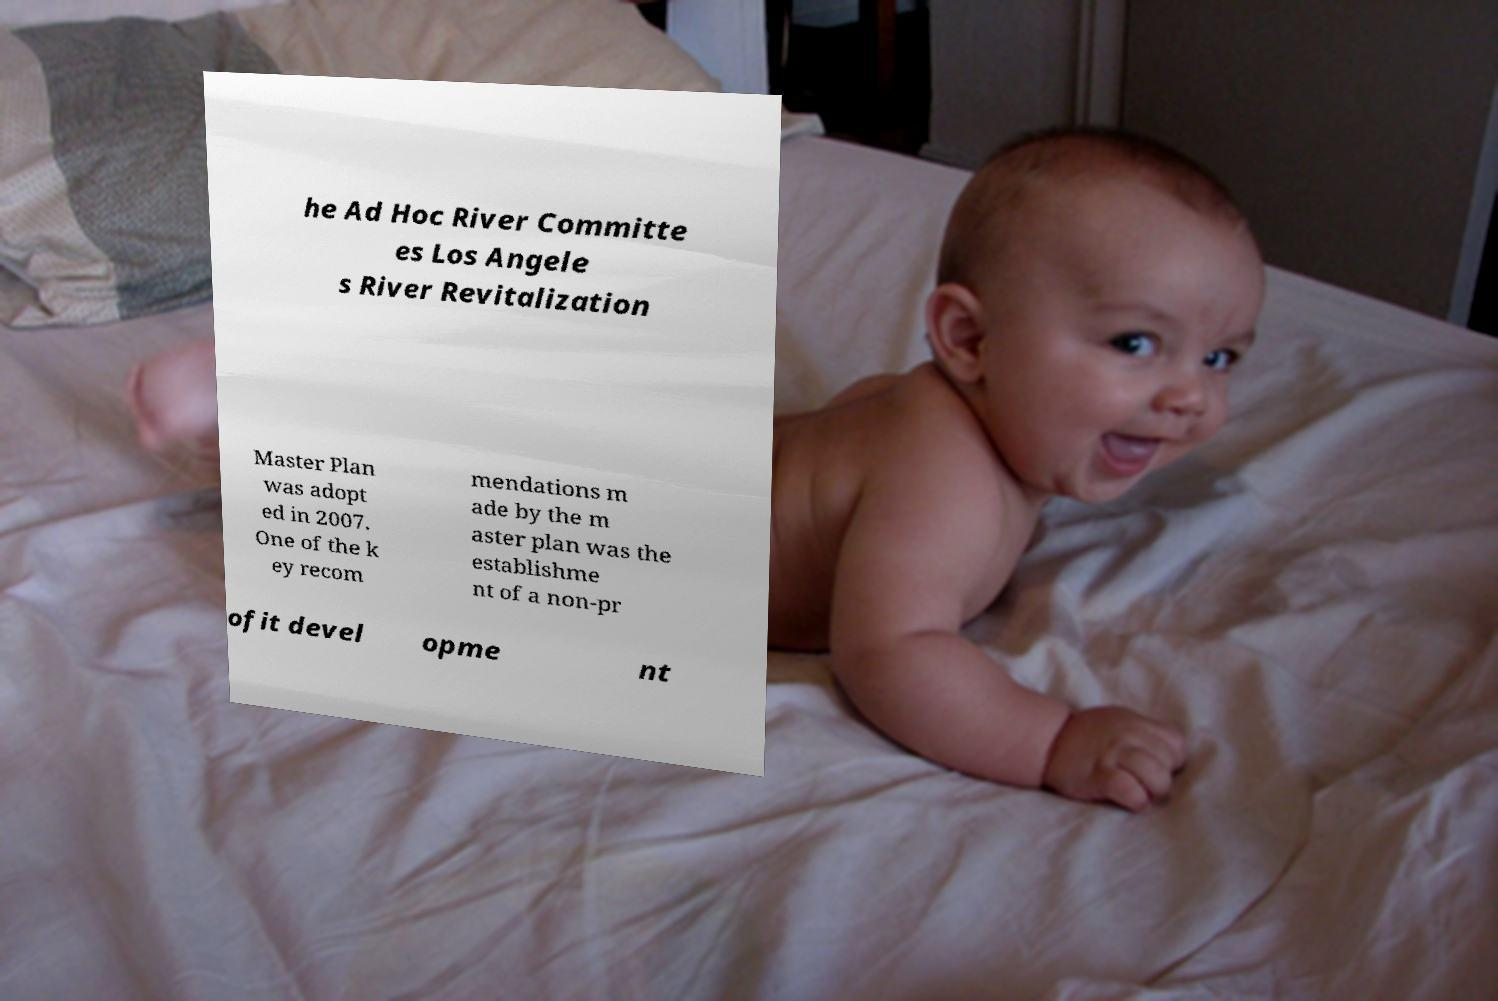For documentation purposes, I need the text within this image transcribed. Could you provide that? he Ad Hoc River Committe es Los Angele s River Revitalization Master Plan was adopt ed in 2007. One of the k ey recom mendations m ade by the m aster plan was the establishme nt of a non-pr ofit devel opme nt 